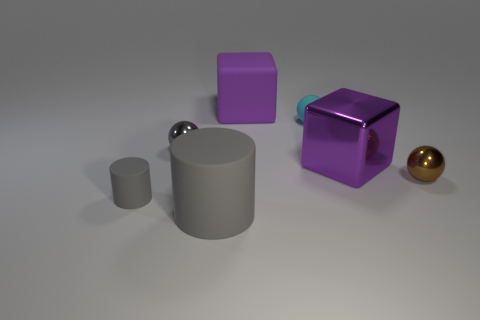Add 2 small cyan rubber objects. How many objects exist? 9 Subtract all gray balls. How many balls are left? 2 Subtract all brown spheres. How many spheres are left? 2 Subtract 2 spheres. How many spheres are left? 1 Subtract all cubes. How many objects are left? 5 Add 4 big gray objects. How many big gray objects are left? 5 Add 6 red shiny blocks. How many red shiny blocks exist? 6 Subtract 0 cyan cubes. How many objects are left? 7 Subtract all gray balls. Subtract all red blocks. How many balls are left? 2 Subtract all brown matte objects. Subtract all brown metallic objects. How many objects are left? 6 